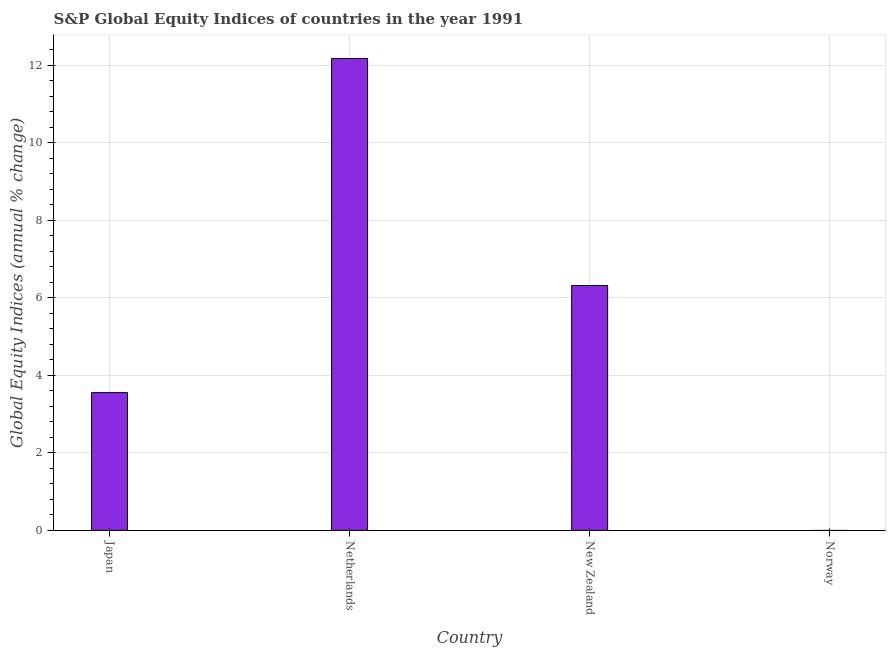Does the graph contain grids?
Provide a succinct answer. Yes. What is the title of the graph?
Keep it short and to the point. S&P Global Equity Indices of countries in the year 1991. What is the label or title of the Y-axis?
Your answer should be very brief. Global Equity Indices (annual % change). What is the s&p global equity indices in New Zealand?
Keep it short and to the point. 6.32. Across all countries, what is the maximum s&p global equity indices?
Your answer should be compact. 12.18. What is the sum of the s&p global equity indices?
Give a very brief answer. 22.05. What is the difference between the s&p global equity indices in Netherlands and New Zealand?
Offer a very short reply. 5.86. What is the average s&p global equity indices per country?
Keep it short and to the point. 5.51. What is the median s&p global equity indices?
Make the answer very short. 4.94. In how many countries, is the s&p global equity indices greater than 9.6 %?
Make the answer very short. 1. What is the ratio of the s&p global equity indices in Japan to that in New Zealand?
Provide a succinct answer. 0.56. Is the s&p global equity indices in Japan less than that in Netherlands?
Your answer should be compact. Yes. What is the difference between the highest and the second highest s&p global equity indices?
Your answer should be compact. 5.86. What is the difference between the highest and the lowest s&p global equity indices?
Offer a terse response. 12.18. In how many countries, is the s&p global equity indices greater than the average s&p global equity indices taken over all countries?
Offer a terse response. 2. Are all the bars in the graph horizontal?
Keep it short and to the point. No. Are the values on the major ticks of Y-axis written in scientific E-notation?
Give a very brief answer. No. What is the Global Equity Indices (annual % change) of Japan?
Ensure brevity in your answer.  3.55. What is the Global Equity Indices (annual % change) of Netherlands?
Make the answer very short. 12.18. What is the Global Equity Indices (annual % change) in New Zealand?
Provide a short and direct response. 6.32. What is the Global Equity Indices (annual % change) in Norway?
Provide a succinct answer. 0. What is the difference between the Global Equity Indices (annual % change) in Japan and Netherlands?
Your answer should be very brief. -8.62. What is the difference between the Global Equity Indices (annual % change) in Japan and New Zealand?
Provide a short and direct response. -2.76. What is the difference between the Global Equity Indices (annual % change) in Netherlands and New Zealand?
Make the answer very short. 5.86. What is the ratio of the Global Equity Indices (annual % change) in Japan to that in Netherlands?
Provide a succinct answer. 0.29. What is the ratio of the Global Equity Indices (annual % change) in Japan to that in New Zealand?
Your answer should be very brief. 0.56. What is the ratio of the Global Equity Indices (annual % change) in Netherlands to that in New Zealand?
Make the answer very short. 1.93. 